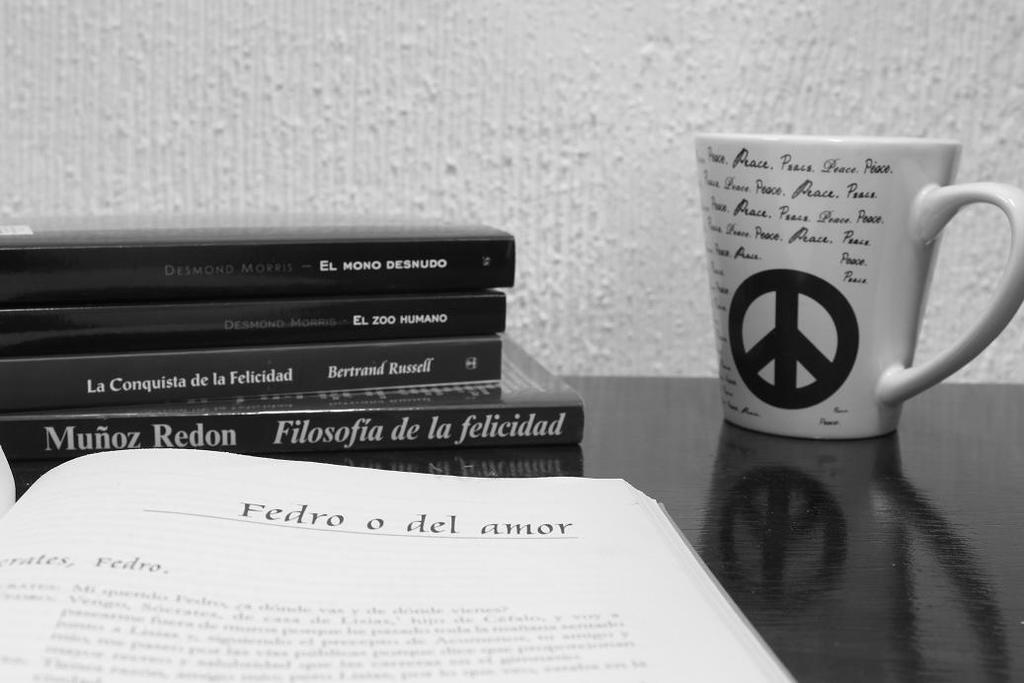Provide a one-sentence caption for the provided image. A coffee mug with the peace symbol on it next to some books by Munoz Redon. 